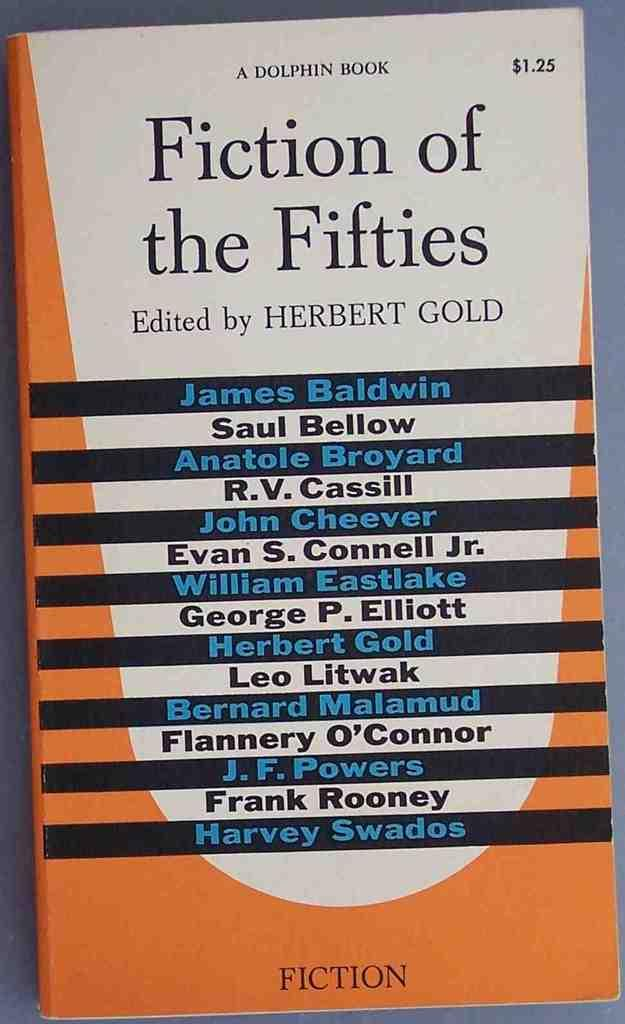<image>
Give a short and clear explanation of the subsequent image. Orange and white book for Fiction of the Fifties and the authors in black and blue. 